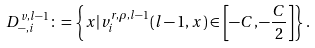<formula> <loc_0><loc_0><loc_500><loc_500>D ^ { v , l - 1 } _ { - , i } \colon = \left \{ x | v ^ { r , \rho , l - 1 } _ { i } ( l - 1 , x ) \in \left [ - C , - \frac { C } { 2 } \right ] \right \} .</formula> 